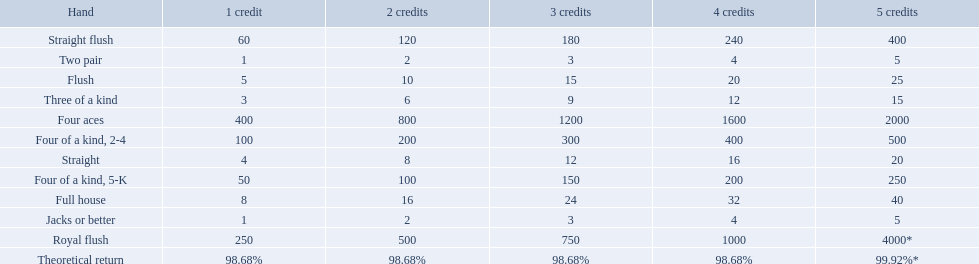What is the higher amount of points for one credit you can get from the best four of a kind 100. What type is it? Four of a kind, 2-4. 